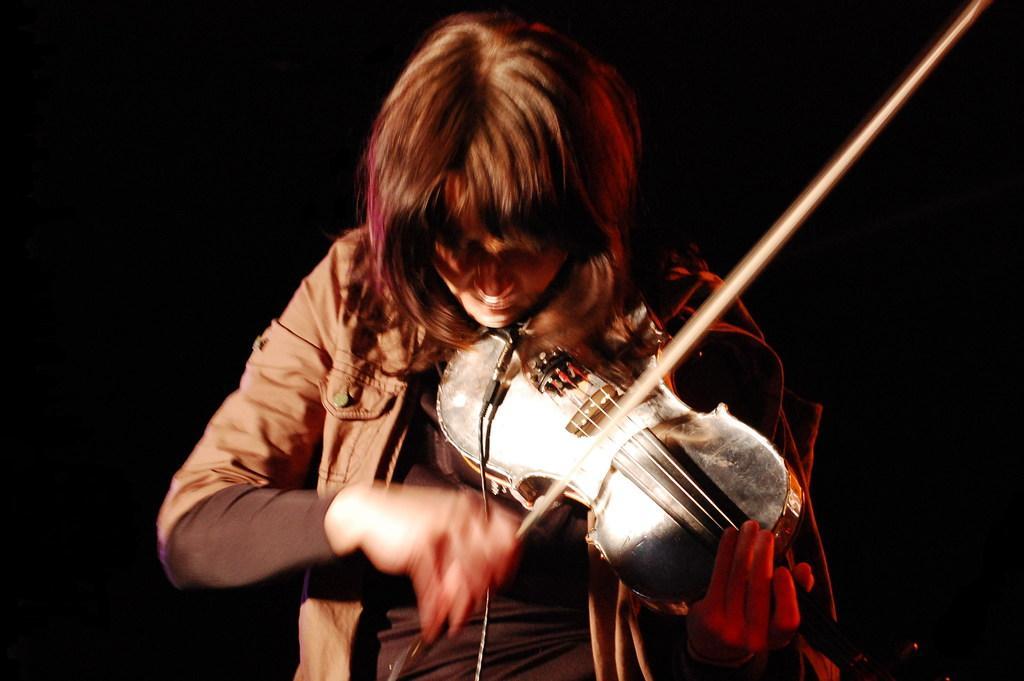Describe this image in one or two sentences. This person wore jacket, holds stick and violin. 